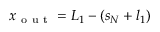Convert formula to latex. <formula><loc_0><loc_0><loc_500><loc_500>x _ { o u t } = L _ { 1 } - \left ( s _ { N } + l _ { 1 } \right )</formula> 